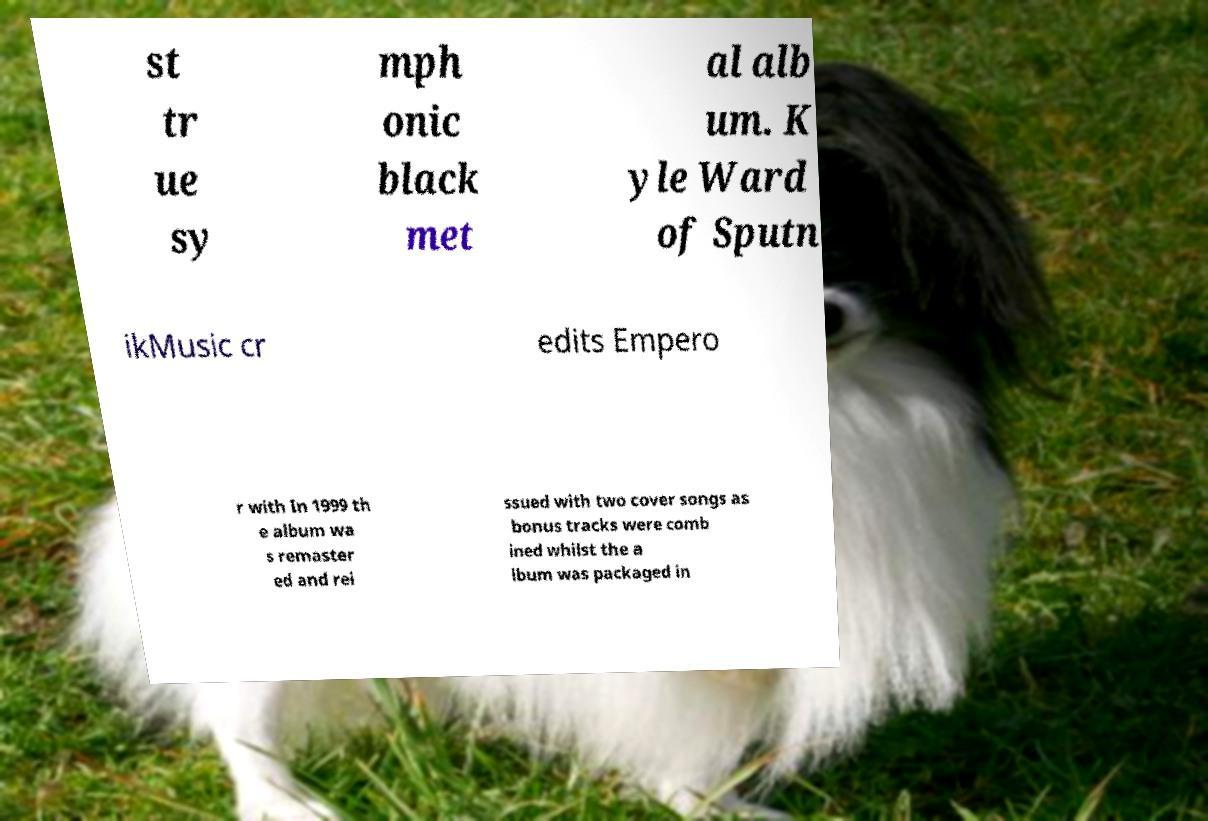What messages or text are displayed in this image? I need them in a readable, typed format. st tr ue sy mph onic black met al alb um. K yle Ward of Sputn ikMusic cr edits Empero r with In 1999 th e album wa s remaster ed and rei ssued with two cover songs as bonus tracks were comb ined whilst the a lbum was packaged in 